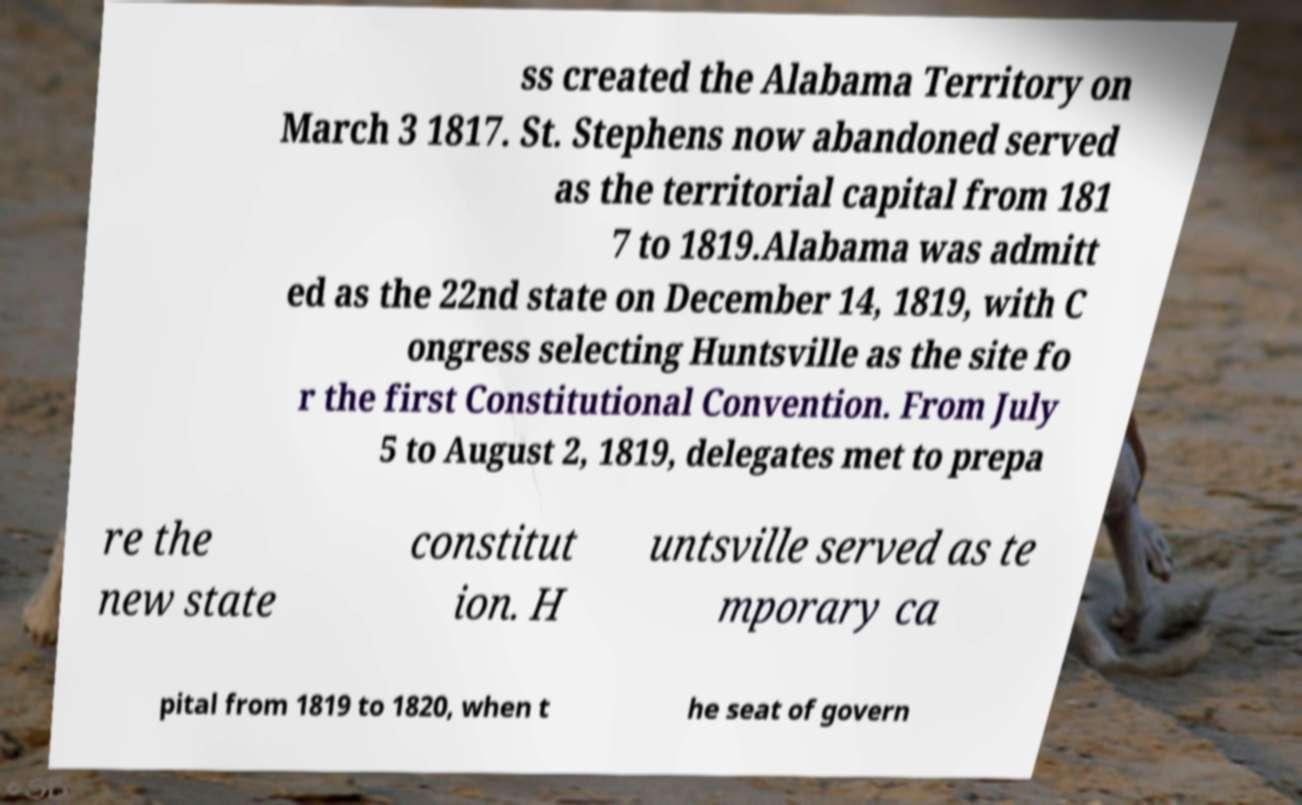Could you assist in decoding the text presented in this image and type it out clearly? ss created the Alabama Territory on March 3 1817. St. Stephens now abandoned served as the territorial capital from 181 7 to 1819.Alabama was admitt ed as the 22nd state on December 14, 1819, with C ongress selecting Huntsville as the site fo r the first Constitutional Convention. From July 5 to August 2, 1819, delegates met to prepa re the new state constitut ion. H untsville served as te mporary ca pital from 1819 to 1820, when t he seat of govern 